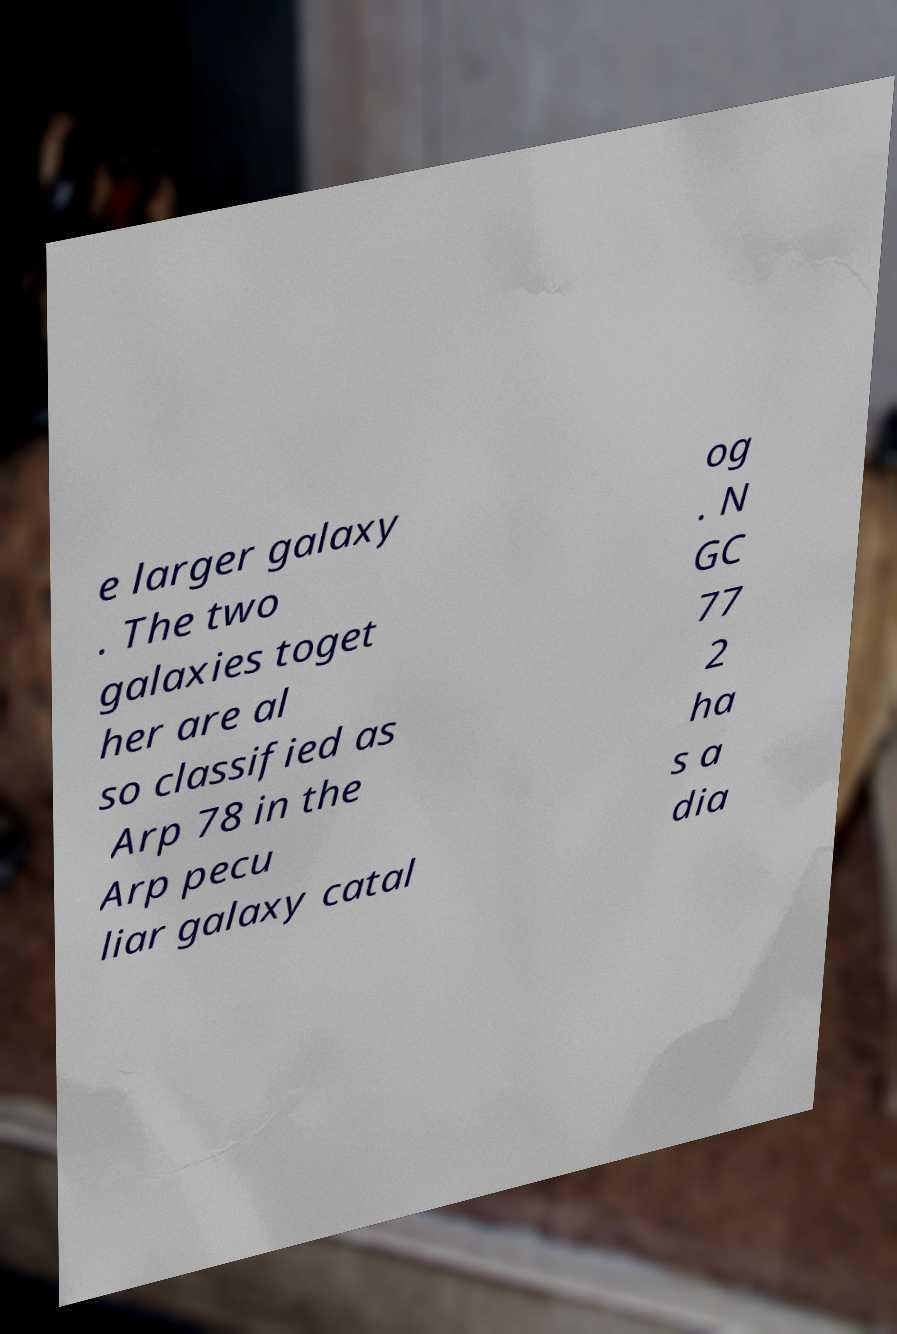I need the written content from this picture converted into text. Can you do that? e larger galaxy . The two galaxies toget her are al so classified as Arp 78 in the Arp pecu liar galaxy catal og . N GC 77 2 ha s a dia 